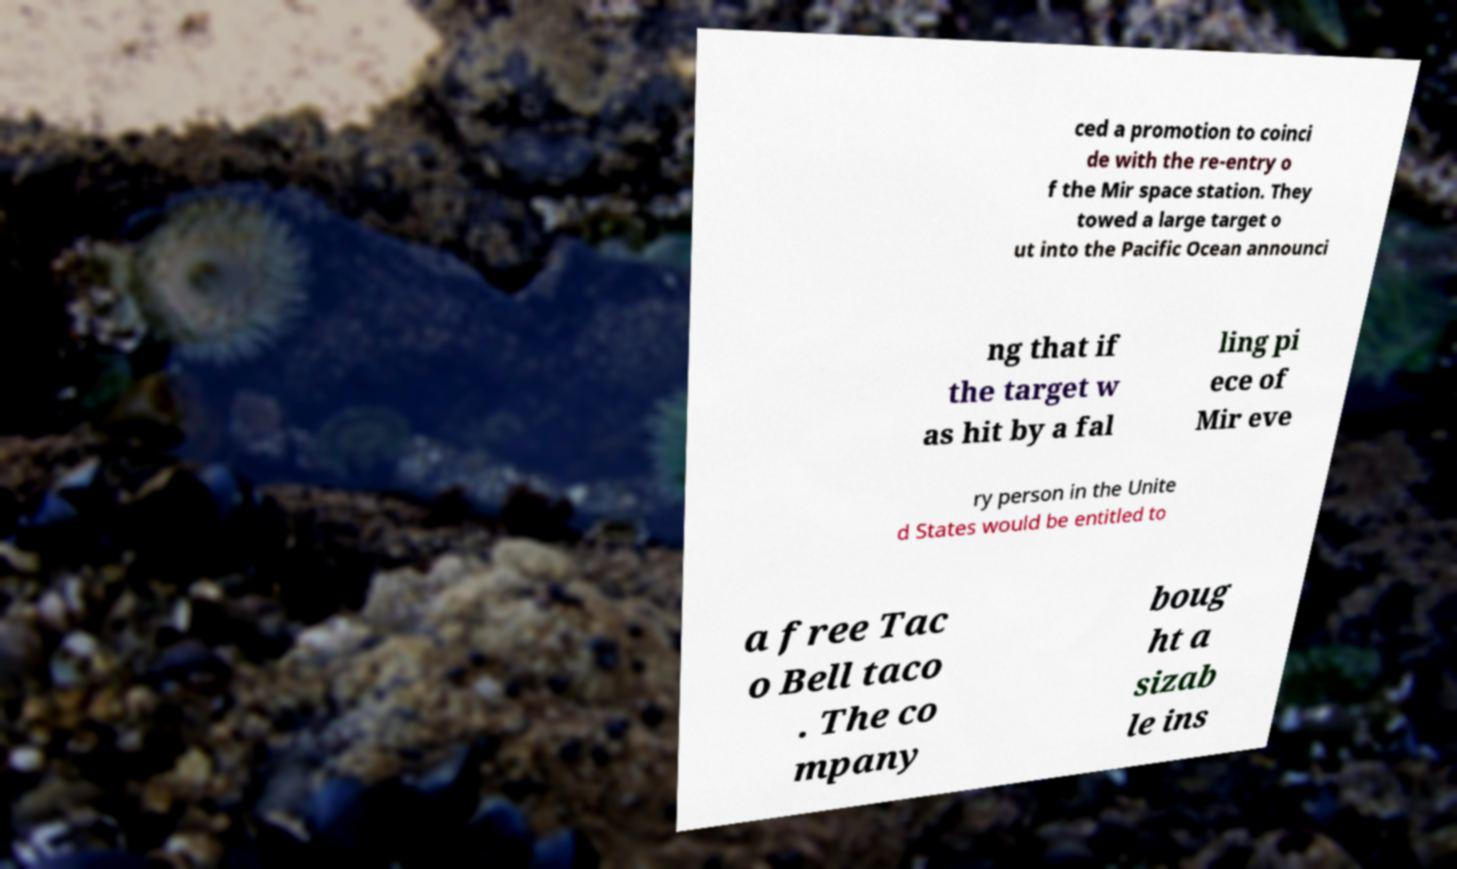What messages or text are displayed in this image? I need them in a readable, typed format. ced a promotion to coinci de with the re-entry o f the Mir space station. They towed a large target o ut into the Pacific Ocean announci ng that if the target w as hit by a fal ling pi ece of Mir eve ry person in the Unite d States would be entitled to a free Tac o Bell taco . The co mpany boug ht a sizab le ins 